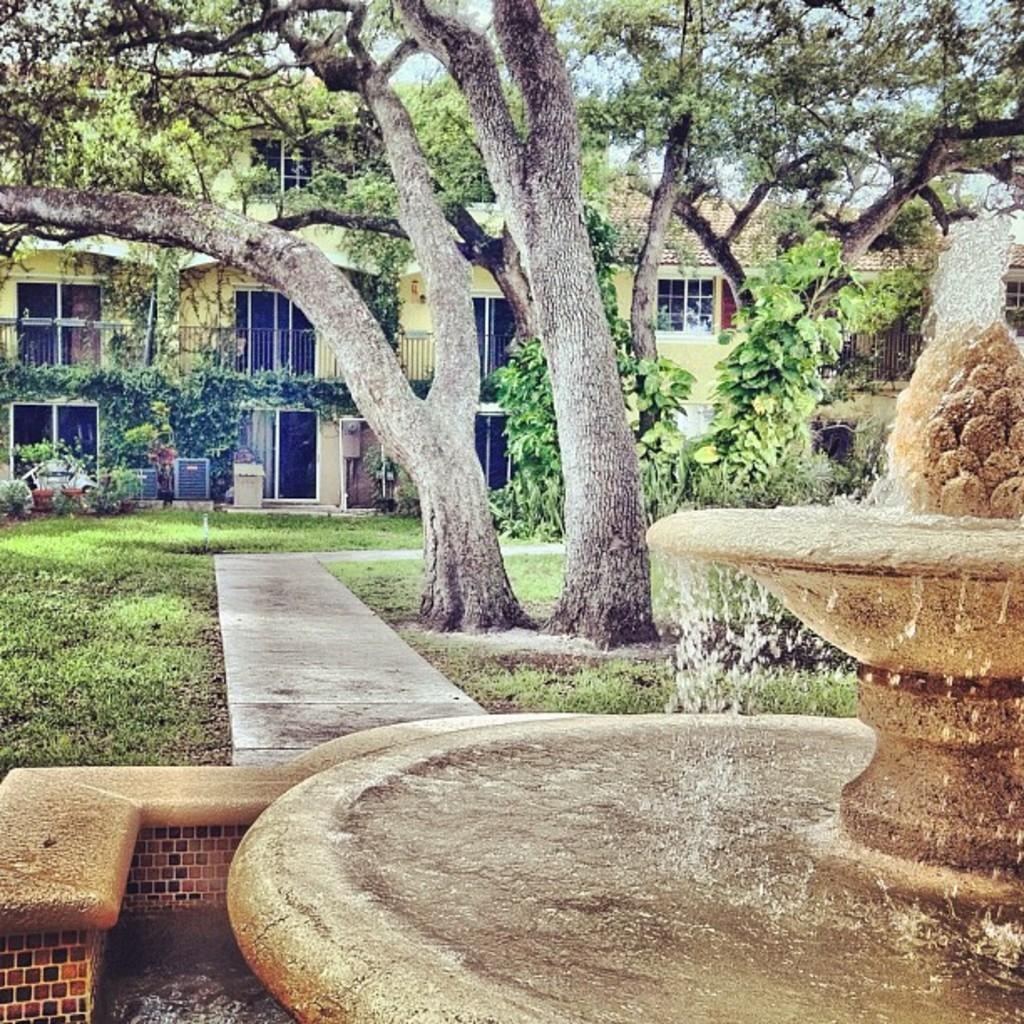What type of terrain is visible in the image? There is grassy land in the image. What natural elements can be seen in the image? There are trees in the image. Where are the trees located in relation to the rest of the image? The trees are in the middle of the image. What structure can be seen in the background of the image? There is a building in the background of the image. What feature is located at the bottom of the image? There is a water fountain at the bottom of the image. What type of approval is required for the current order in the image? There is no mention of an order or approval in the image; it features grassy land, trees, a building, and a water fountain. 